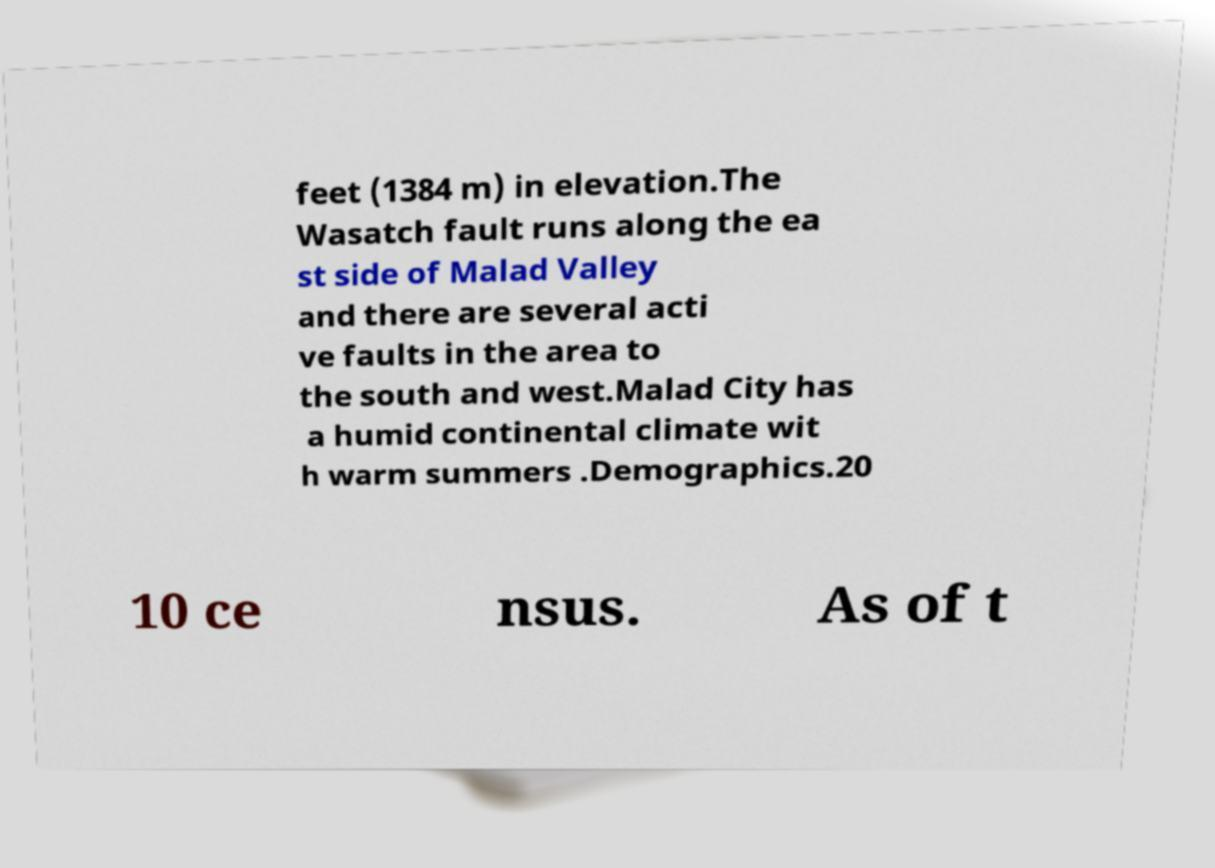Could you extract and type out the text from this image? feet (1384 m) in elevation.The Wasatch fault runs along the ea st side of Malad Valley and there are several acti ve faults in the area to the south and west.Malad City has a humid continental climate wit h warm summers .Demographics.20 10 ce nsus. As of t 